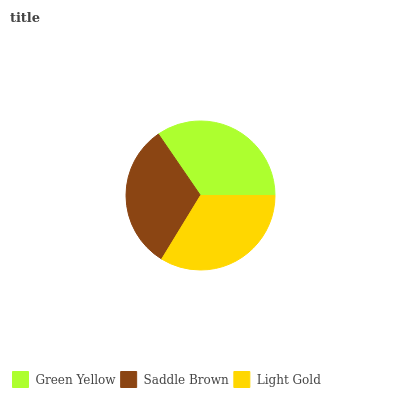Is Saddle Brown the minimum?
Answer yes or no. Yes. Is Green Yellow the maximum?
Answer yes or no. Yes. Is Light Gold the minimum?
Answer yes or no. No. Is Light Gold the maximum?
Answer yes or no. No. Is Light Gold greater than Saddle Brown?
Answer yes or no. Yes. Is Saddle Brown less than Light Gold?
Answer yes or no. Yes. Is Saddle Brown greater than Light Gold?
Answer yes or no. No. Is Light Gold less than Saddle Brown?
Answer yes or no. No. Is Light Gold the high median?
Answer yes or no. Yes. Is Light Gold the low median?
Answer yes or no. Yes. Is Saddle Brown the high median?
Answer yes or no. No. Is Green Yellow the low median?
Answer yes or no. No. 